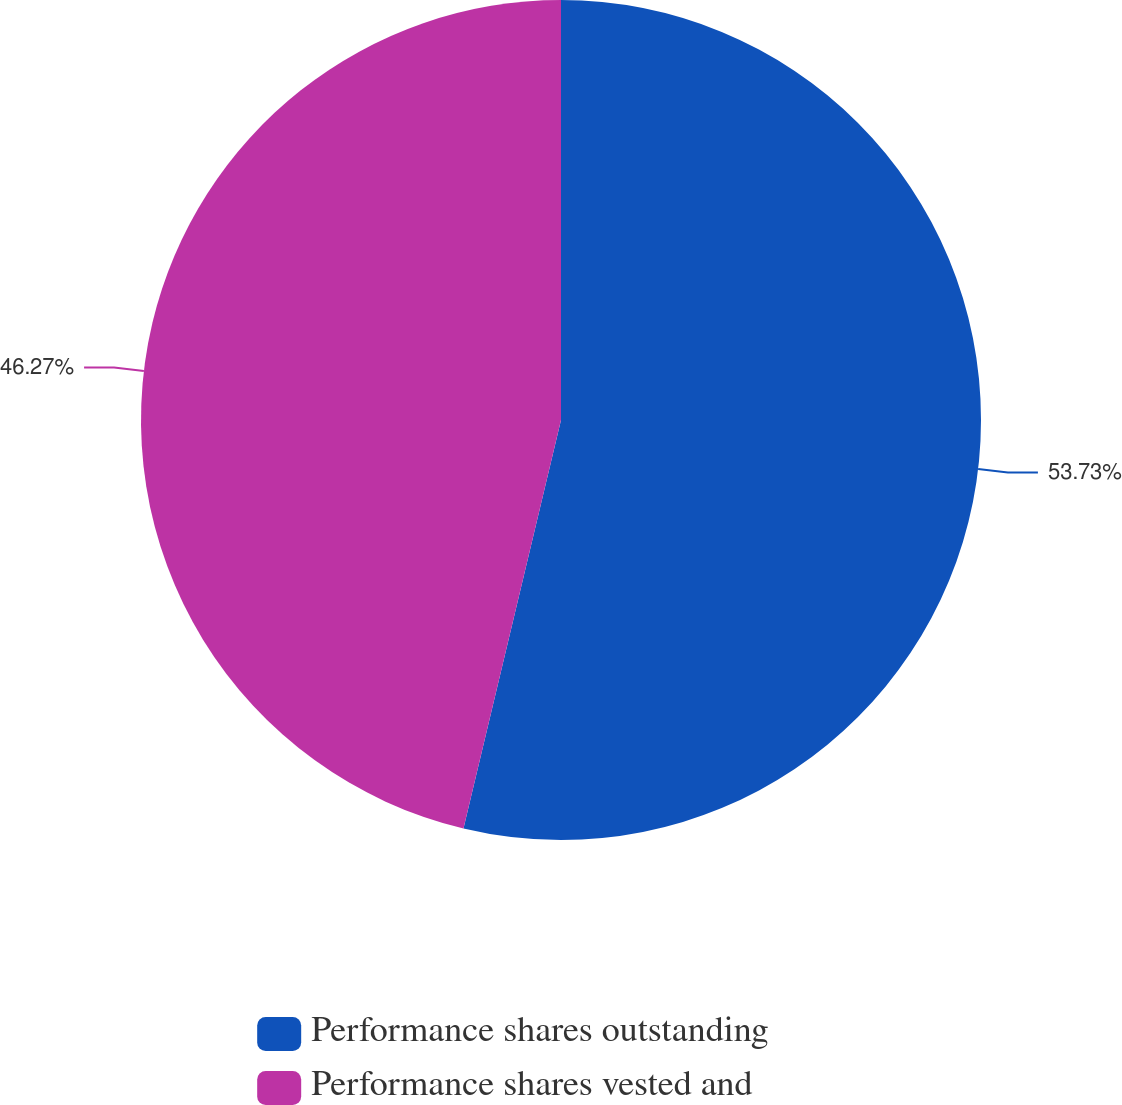Convert chart. <chart><loc_0><loc_0><loc_500><loc_500><pie_chart><fcel>Performance shares outstanding<fcel>Performance shares vested and<nl><fcel>53.73%<fcel>46.27%<nl></chart> 